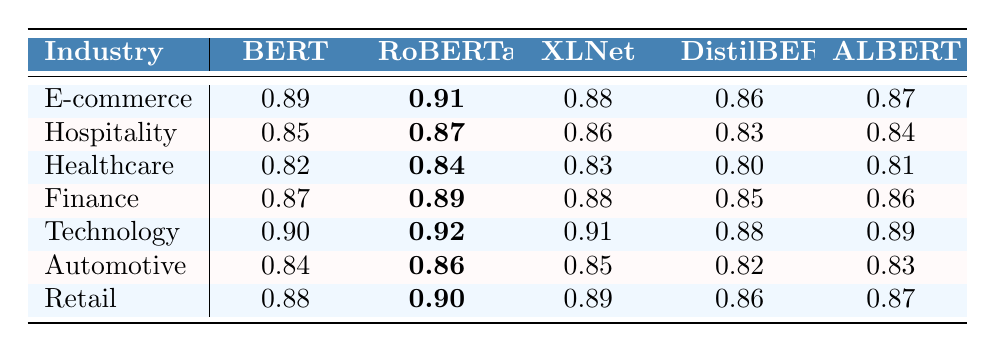What is the highest accuracy achieved by the RoBERTa model across all industries? The RoBERTa model achieved its highest accuracy of 0.92 in the Technology industry, which is the maximum value for RoBERTa in the table.
Answer: 0.92 Which industry had the lowest accuracy score for the BERT model? Among all the industries listed, the Healthcare sector had the lowest accuracy for the BERT model, which is 0.82.
Answer: Healthcare What is the average accuracy of the XLNet model across all industries? To find the average, we sum the XLNet values: (0.88 + 0.86 + 0.83 + 0.88 + 0.91 + 0.85 + 0.89) = 6.10. There are 7 industries, so the average is 6.10/7 ≈ 0.87.
Answer: 0.87 Did the DistilBERT model perform better in the Retail industry compared to the Automotive industry? The DistilBERT accuracy for Retail is 0.86, while for Automotive it is 0.82. Since 0.86 is higher than 0.82, DistilBERT did perform better in Retail.
Answer: Yes Which model overall has the highest accuracy in the Finance industry? Looking at the Finance industry, RoBERTa has the highest accuracy of 0.89 compared to BERT (0.87), XLNet (0.88), DistilBERT (0.85), and ALBERT (0.86).
Answer: RoBERTa What is the difference between the highest and lowest accuracy recorded in the E-commerce industry? The highest accuracy in E-commerce is 0.91 (RoBERTa) and the lowest is 0.86 (DistilBERT). Therefore, the difference is 0.91 - 0.86 = 0.05.
Answer: 0.05 Which NLP model shows the most consistent performance across different industries? To determine consistency, we compare the range of accuracies for each model. Analyzing the data, DistilBERT ranges from 0.80 to 0.88 (a difference of 0.08), while others have wider ranges. Hence, DistilBERT shows the most consistency.
Answer: DistilBERT Is it true that the XLNet model performed the worst in the Hospitality sector? In the Hospitality sector, the XLNet accuracy is 0.86, which is not the worst. DistilBERT has the lowest accuracy of 0.83 in this sector.
Answer: No Which industry benefits the most from using RoBERTa, based on the accuracy scores? RoBERTa has the highest accuracy of 0.92 in the Technology industry, so this industry benefits the most from using the RoBERTa model.
Answer: Technology 